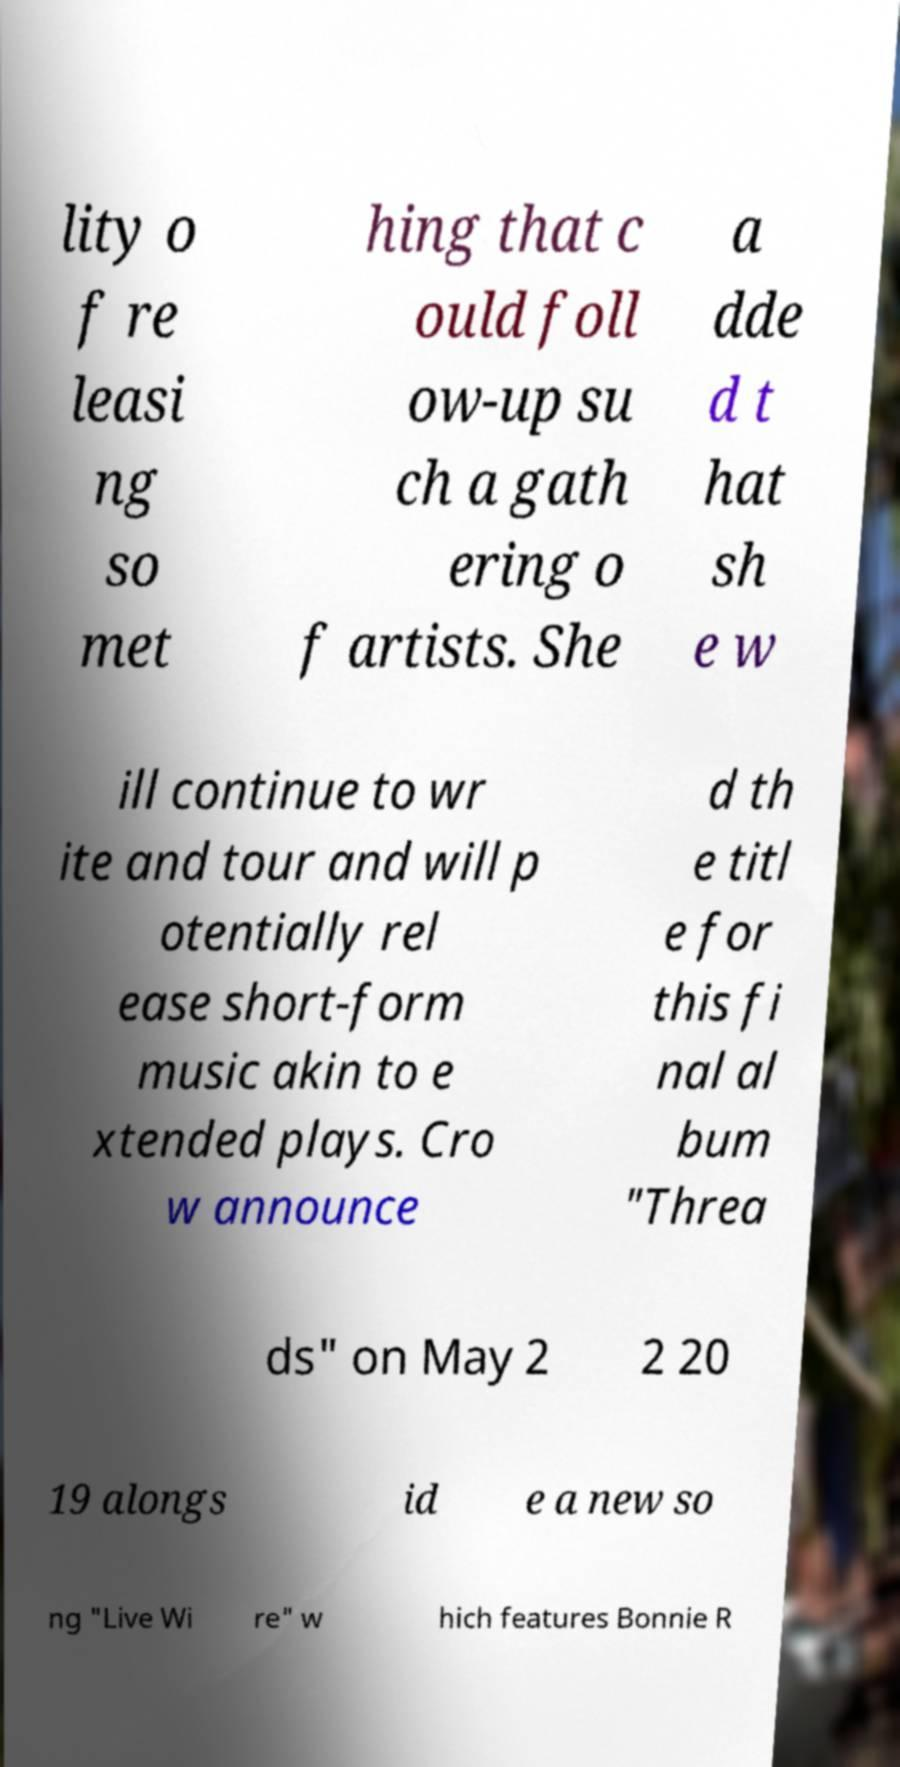For documentation purposes, I need the text within this image transcribed. Could you provide that? lity o f re leasi ng so met hing that c ould foll ow-up su ch a gath ering o f artists. She a dde d t hat sh e w ill continue to wr ite and tour and will p otentially rel ease short-form music akin to e xtended plays. Cro w announce d th e titl e for this fi nal al bum "Threa ds" on May 2 2 20 19 alongs id e a new so ng "Live Wi re" w hich features Bonnie R 